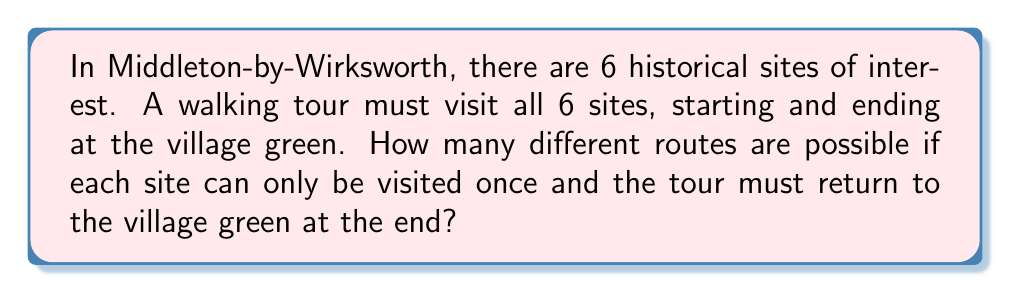Teach me how to tackle this problem. Let's approach this step-by-step:

1) First, we need to recognize that this is a variation of the Traveling Salesman Problem.

2) We have 6 sites to visit, plus the village green as the start and end point.

3) The number of ways to arrange n distinct objects is given by n!. However, we need to make some adjustments:

   a) The village green is fixed as the start and end point, so we only need to arrange the other 6 sites.
   b) Since we return to the starting point, the last choice is forced once we've visited all other sites.

4) Therefore, the number of possible routes is equal to the number of permutations of 5 sites (as the 6th site will be the last one visited before returning to the green).

5) The number of permutations of 5 objects is calculated as:

   $$5! = 5 \times 4 \times 3 \times 2 \times 1 = 120$$

Thus, there are 120 possible routes for the historical walking tour through Middleton-by-Wirksworth.
Answer: 120 